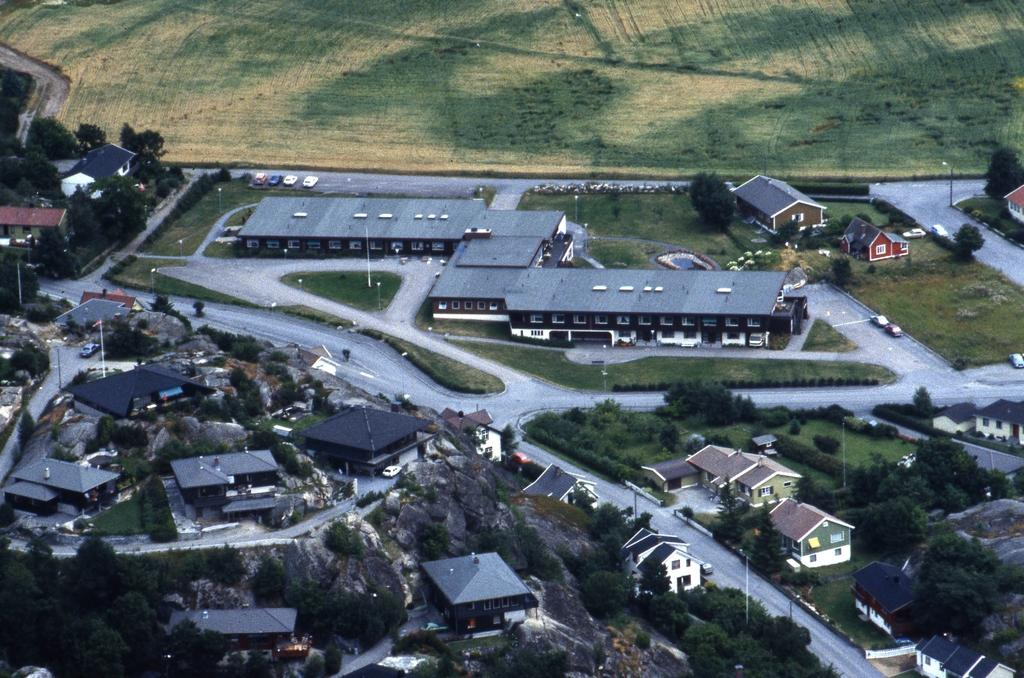What type of view is provided by the image? The image is an aerial view. What can be seen on the ground in the image? There is ground visible in the image, along with motor vehicles on the roads, street poles, street lights, trees, bushes, buildings, and rocks. Can you describe the types of structures visible in the image? Buildings are visible in the image, along with street poles and street lights. What natural elements can be seen in the image? Trees, bushes, and rocks are present in the image. What type of fiction is being read by the hall in the image? There is no hall or fiction present in the image; it is an aerial view of a landscape with various elements. What color is the ball in the image? There is no ball present in the image. 